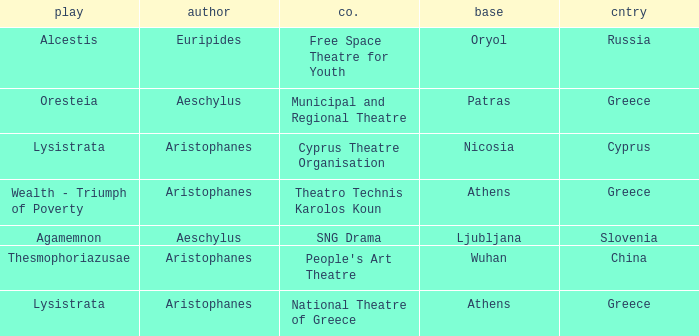Can you parse all the data within this table? {'header': ['play', 'author', 'co.', 'base', 'cntry'], 'rows': [['Alcestis', 'Euripides', 'Free Space Theatre for Youth', 'Oryol', 'Russia'], ['Oresteia', 'Aeschylus', 'Municipal and Regional Theatre', 'Patras', 'Greece'], ['Lysistrata', 'Aristophanes', 'Cyprus Theatre Organisation', 'Nicosia', 'Cyprus'], ['Wealth - Triumph of Poverty', 'Aristophanes', 'Theatro Technis Karolos Koun', 'Athens', 'Greece'], ['Agamemnon', 'Aeschylus', 'SNG Drama', 'Ljubljana', 'Slovenia'], ['Thesmophoriazusae', 'Aristophanes', "People's Art Theatre", 'Wuhan', 'China'], ['Lysistrata', 'Aristophanes', 'National Theatre of Greece', 'Athens', 'Greece']]} What is the company when the base is ljubljana? SNG Drama. 